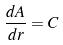Convert formula to latex. <formula><loc_0><loc_0><loc_500><loc_500>\frac { d A } { d r } = C</formula> 